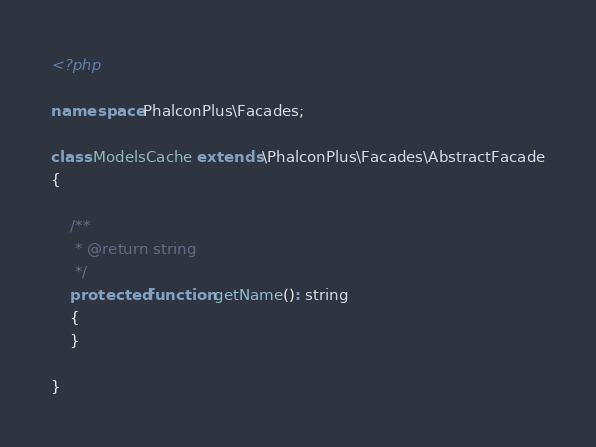Convert code to text. <code><loc_0><loc_0><loc_500><loc_500><_PHP_><?php

namespace PhalconPlus\Facades;

class ModelsCache extends \PhalconPlus\Facades\AbstractFacade
{

    /**
     * @return string
     */
    protected function getName(): string
    {
    }

}
</code> 